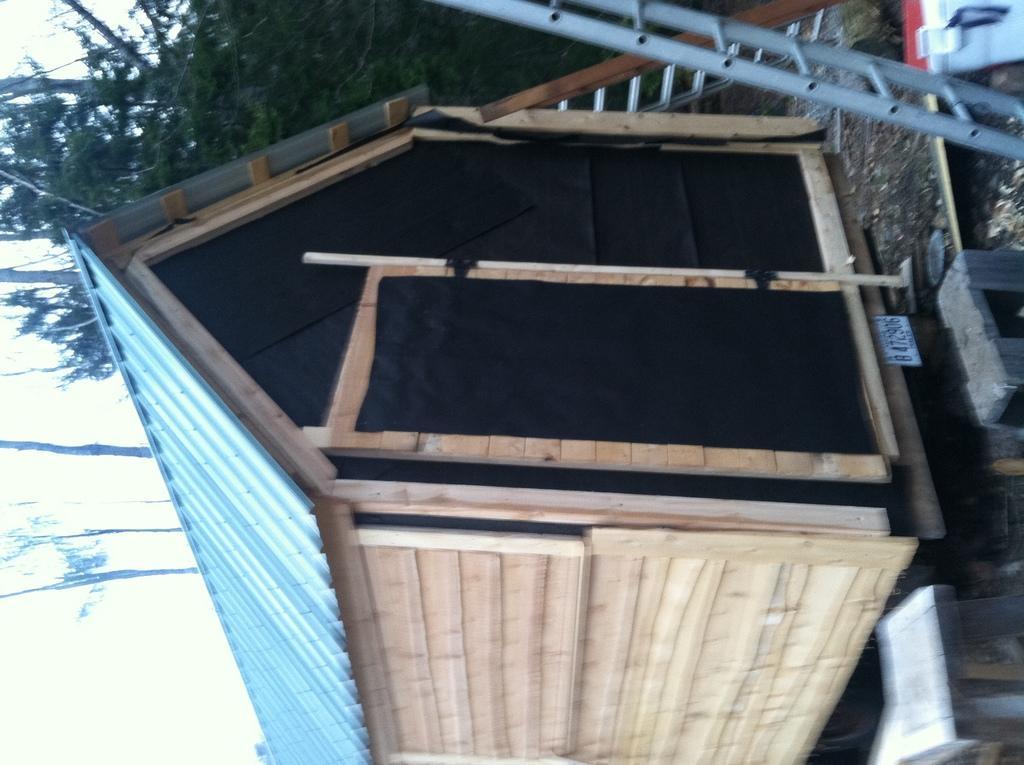In one or two sentences, can you explain what this image depicts? In this picture we can see the small wooden shed in the image. In the front there is a silver ladder. Behind we can see some trees. 